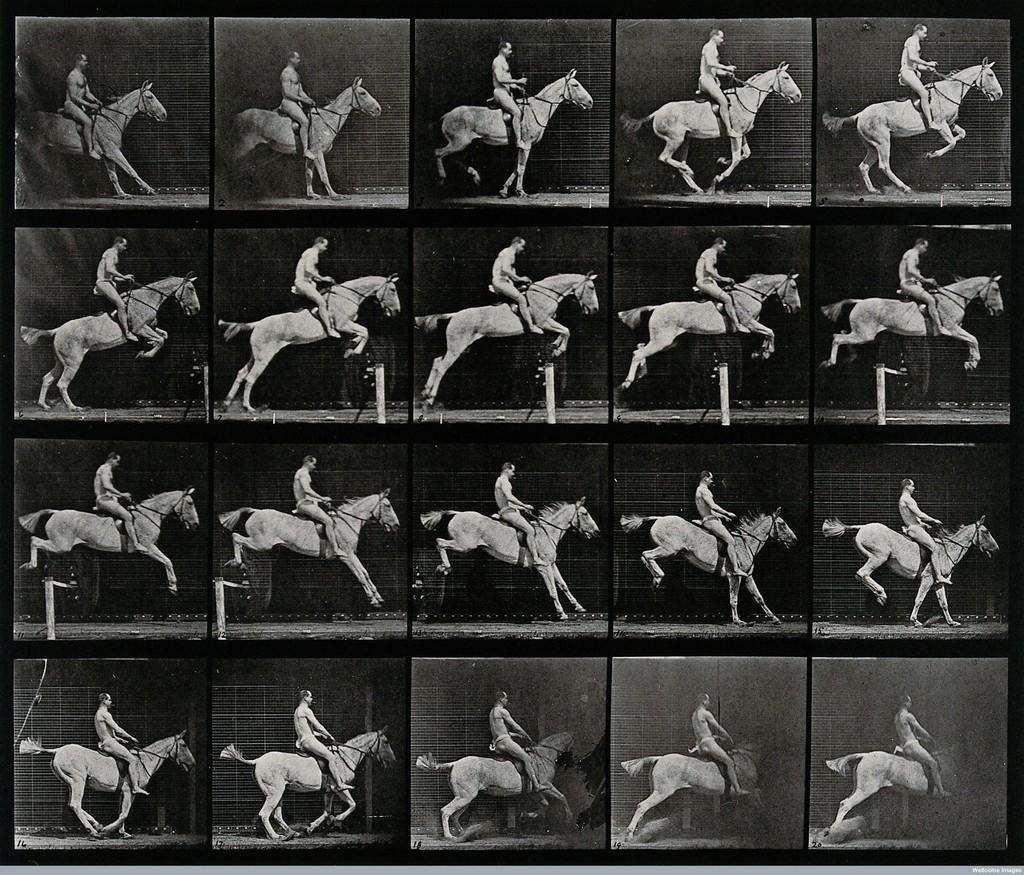What type of building is shown in the image? There is a college in the image. What activity is the man in the image engaged in? The man is sitting on a horse in the image. What obstacle is present in the image? There is a hurdle in the image. What type of weather can be seen in the image? The provided facts do not mention any weather conditions, so it cannot be determined from the image. What color is the vest the man is wearing in the image? There is no mention of a vest in the provided facts, so it cannot be determined from the image. 